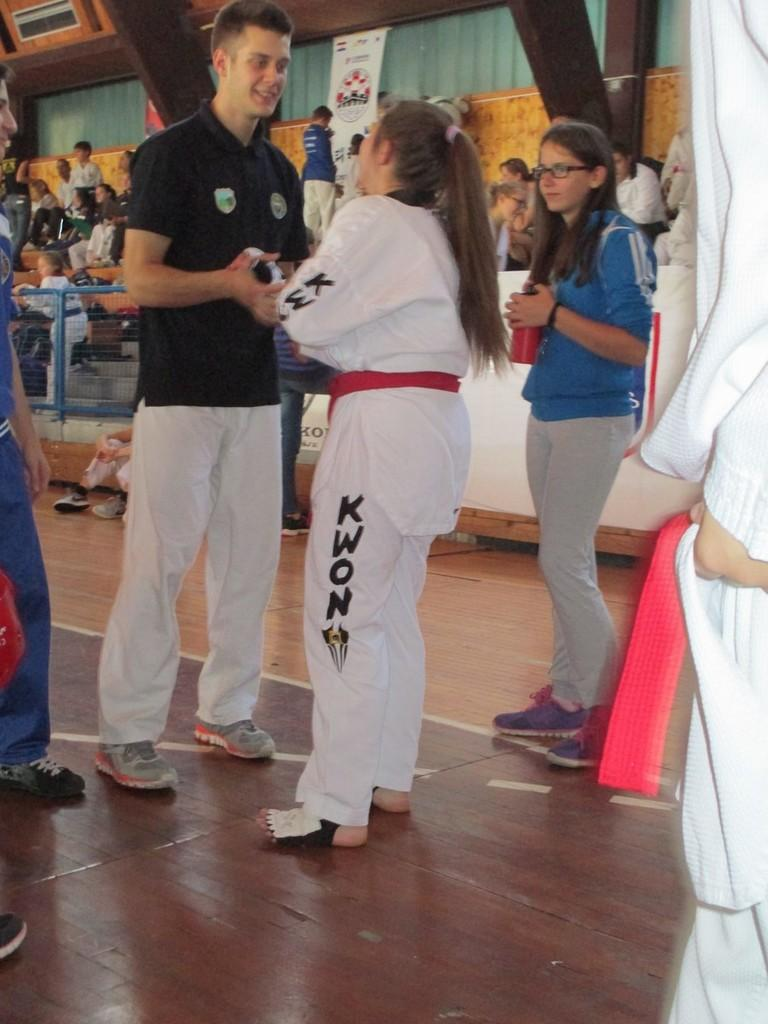Provide a one-sentence caption for the provided image. a girl that has the letters kwon on their pants. 